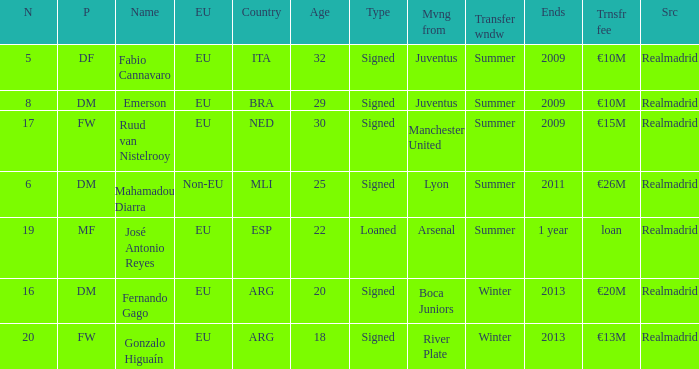What is the type of the player whose transfer fee was €20m? Signed. 